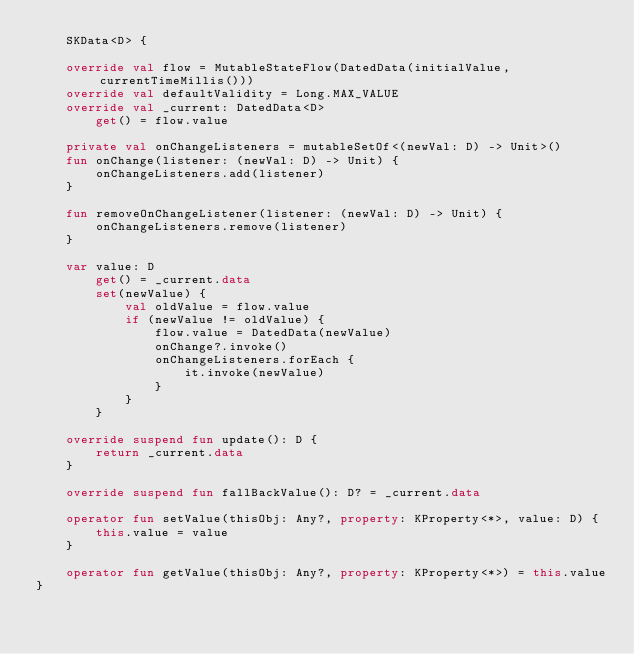Convert code to text. <code><loc_0><loc_0><loc_500><loc_500><_Kotlin_>    SKData<D> {

    override val flow = MutableStateFlow(DatedData(initialValue, currentTimeMillis()))
    override val defaultValidity = Long.MAX_VALUE
    override val _current: DatedData<D>
        get() = flow.value

    private val onChangeListeners = mutableSetOf<(newVal: D) -> Unit>()
    fun onChange(listener: (newVal: D) -> Unit) {
        onChangeListeners.add(listener)
    }

    fun removeOnChangeListener(listener: (newVal: D) -> Unit) {
        onChangeListeners.remove(listener)
    }

    var value: D
        get() = _current.data
        set(newValue) {
            val oldValue = flow.value
            if (newValue != oldValue) {
                flow.value = DatedData(newValue)
                onChange?.invoke()
                onChangeListeners.forEach {
                    it.invoke(newValue)
                }
            }
        }

    override suspend fun update(): D {
        return _current.data
    }

    override suspend fun fallBackValue(): D? = _current.data

    operator fun setValue(thisObj: Any?, property: KProperty<*>, value: D) {
        this.value = value
    }

    operator fun getValue(thisObj: Any?, property: KProperty<*>) = this.value
}
</code> 